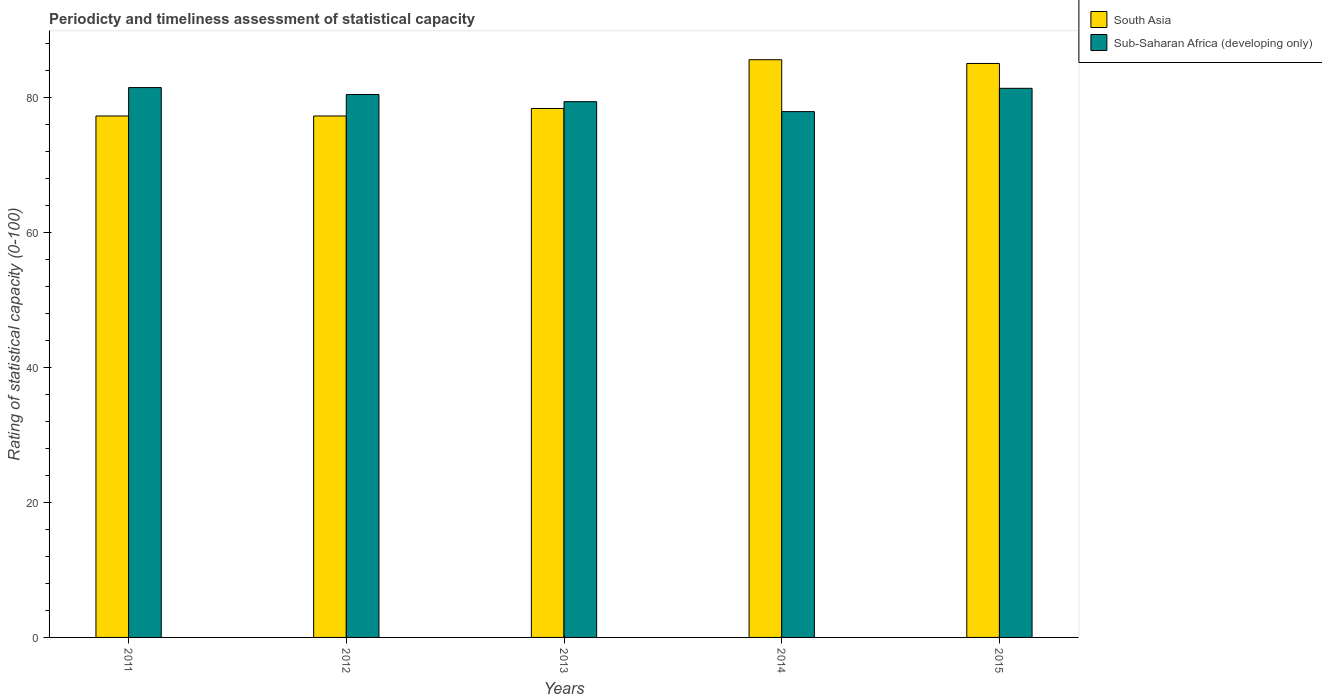How many groups of bars are there?
Provide a short and direct response. 5. How many bars are there on the 2nd tick from the left?
Make the answer very short. 2. How many bars are there on the 4th tick from the right?
Make the answer very short. 2. In how many cases, is the number of bars for a given year not equal to the number of legend labels?
Offer a terse response. 0. What is the rating of statistical capacity in South Asia in 2012?
Provide a succinct answer. 77.22. Across all years, what is the maximum rating of statistical capacity in Sub-Saharan Africa (developing only)?
Ensure brevity in your answer.  81.43. Across all years, what is the minimum rating of statistical capacity in Sub-Saharan Africa (developing only)?
Offer a very short reply. 77.87. In which year was the rating of statistical capacity in Sub-Saharan Africa (developing only) maximum?
Make the answer very short. 2011. In which year was the rating of statistical capacity in South Asia minimum?
Offer a terse response. 2011. What is the total rating of statistical capacity in South Asia in the graph?
Your answer should be compact. 403.33. What is the difference between the rating of statistical capacity in Sub-Saharan Africa (developing only) in 2011 and that in 2012?
Give a very brief answer. 1.03. What is the difference between the rating of statistical capacity in Sub-Saharan Africa (developing only) in 2015 and the rating of statistical capacity in South Asia in 2012?
Make the answer very short. 4.1. What is the average rating of statistical capacity in South Asia per year?
Ensure brevity in your answer.  80.67. In the year 2013, what is the difference between the rating of statistical capacity in South Asia and rating of statistical capacity in Sub-Saharan Africa (developing only)?
Provide a short and direct response. -1.01. What is the ratio of the rating of statistical capacity in Sub-Saharan Africa (developing only) in 2013 to that in 2014?
Your answer should be very brief. 1.02. Is the rating of statistical capacity in South Asia in 2013 less than that in 2015?
Ensure brevity in your answer.  Yes. Is the difference between the rating of statistical capacity in South Asia in 2012 and 2013 greater than the difference between the rating of statistical capacity in Sub-Saharan Africa (developing only) in 2012 and 2013?
Offer a terse response. No. What is the difference between the highest and the second highest rating of statistical capacity in South Asia?
Provide a short and direct response. 0.56. What is the difference between the highest and the lowest rating of statistical capacity in Sub-Saharan Africa (developing only)?
Offer a very short reply. 3.56. Is the sum of the rating of statistical capacity in South Asia in 2012 and 2013 greater than the maximum rating of statistical capacity in Sub-Saharan Africa (developing only) across all years?
Provide a succinct answer. Yes. What does the 1st bar from the left in 2014 represents?
Provide a succinct answer. South Asia. What does the 1st bar from the right in 2015 represents?
Give a very brief answer. Sub-Saharan Africa (developing only). How many bars are there?
Keep it short and to the point. 10. What is the difference between two consecutive major ticks on the Y-axis?
Provide a succinct answer. 20. Does the graph contain grids?
Keep it short and to the point. No. Where does the legend appear in the graph?
Keep it short and to the point. Top right. How are the legend labels stacked?
Give a very brief answer. Vertical. What is the title of the graph?
Your answer should be compact. Periodicty and timeliness assessment of statistical capacity. Does "Bangladesh" appear as one of the legend labels in the graph?
Provide a short and direct response. No. What is the label or title of the X-axis?
Offer a very short reply. Years. What is the label or title of the Y-axis?
Your answer should be compact. Rating of statistical capacity (0-100). What is the Rating of statistical capacity (0-100) of South Asia in 2011?
Provide a short and direct response. 77.22. What is the Rating of statistical capacity (0-100) in Sub-Saharan Africa (developing only) in 2011?
Provide a succinct answer. 81.43. What is the Rating of statistical capacity (0-100) of South Asia in 2012?
Make the answer very short. 77.22. What is the Rating of statistical capacity (0-100) in Sub-Saharan Africa (developing only) in 2012?
Your answer should be compact. 80.4. What is the Rating of statistical capacity (0-100) in South Asia in 2013?
Your response must be concise. 78.33. What is the Rating of statistical capacity (0-100) in Sub-Saharan Africa (developing only) in 2013?
Make the answer very short. 79.34. What is the Rating of statistical capacity (0-100) of South Asia in 2014?
Your response must be concise. 85.56. What is the Rating of statistical capacity (0-100) of Sub-Saharan Africa (developing only) in 2014?
Provide a succinct answer. 77.87. What is the Rating of statistical capacity (0-100) of South Asia in 2015?
Give a very brief answer. 85. What is the Rating of statistical capacity (0-100) of Sub-Saharan Africa (developing only) in 2015?
Make the answer very short. 81.32. Across all years, what is the maximum Rating of statistical capacity (0-100) in South Asia?
Ensure brevity in your answer.  85.56. Across all years, what is the maximum Rating of statistical capacity (0-100) in Sub-Saharan Africa (developing only)?
Offer a very short reply. 81.43. Across all years, what is the minimum Rating of statistical capacity (0-100) of South Asia?
Provide a succinct answer. 77.22. Across all years, what is the minimum Rating of statistical capacity (0-100) in Sub-Saharan Africa (developing only)?
Offer a terse response. 77.87. What is the total Rating of statistical capacity (0-100) in South Asia in the graph?
Keep it short and to the point. 403.33. What is the total Rating of statistical capacity (0-100) in Sub-Saharan Africa (developing only) in the graph?
Offer a very short reply. 400.35. What is the difference between the Rating of statistical capacity (0-100) of South Asia in 2011 and that in 2012?
Provide a succinct answer. -0. What is the difference between the Rating of statistical capacity (0-100) of Sub-Saharan Africa (developing only) in 2011 and that in 2012?
Give a very brief answer. 1.03. What is the difference between the Rating of statistical capacity (0-100) in South Asia in 2011 and that in 2013?
Provide a succinct answer. -1.11. What is the difference between the Rating of statistical capacity (0-100) in Sub-Saharan Africa (developing only) in 2011 and that in 2013?
Offer a terse response. 2.09. What is the difference between the Rating of statistical capacity (0-100) in South Asia in 2011 and that in 2014?
Provide a succinct answer. -8.33. What is the difference between the Rating of statistical capacity (0-100) in Sub-Saharan Africa (developing only) in 2011 and that in 2014?
Your answer should be very brief. 3.56. What is the difference between the Rating of statistical capacity (0-100) in South Asia in 2011 and that in 2015?
Your answer should be very brief. -7.78. What is the difference between the Rating of statistical capacity (0-100) in Sub-Saharan Africa (developing only) in 2011 and that in 2015?
Offer a terse response. 0.11. What is the difference between the Rating of statistical capacity (0-100) in South Asia in 2012 and that in 2013?
Your answer should be very brief. -1.11. What is the difference between the Rating of statistical capacity (0-100) of Sub-Saharan Africa (developing only) in 2012 and that in 2013?
Your response must be concise. 1.06. What is the difference between the Rating of statistical capacity (0-100) in South Asia in 2012 and that in 2014?
Keep it short and to the point. -8.33. What is the difference between the Rating of statistical capacity (0-100) of Sub-Saharan Africa (developing only) in 2012 and that in 2014?
Offer a very short reply. 2.53. What is the difference between the Rating of statistical capacity (0-100) in South Asia in 2012 and that in 2015?
Your answer should be compact. -7.78. What is the difference between the Rating of statistical capacity (0-100) in Sub-Saharan Africa (developing only) in 2012 and that in 2015?
Offer a terse response. -0.92. What is the difference between the Rating of statistical capacity (0-100) in South Asia in 2013 and that in 2014?
Offer a very short reply. -7.22. What is the difference between the Rating of statistical capacity (0-100) in Sub-Saharan Africa (developing only) in 2013 and that in 2014?
Make the answer very short. 1.47. What is the difference between the Rating of statistical capacity (0-100) of South Asia in 2013 and that in 2015?
Provide a short and direct response. -6.67. What is the difference between the Rating of statistical capacity (0-100) in Sub-Saharan Africa (developing only) in 2013 and that in 2015?
Your answer should be compact. -1.98. What is the difference between the Rating of statistical capacity (0-100) of South Asia in 2014 and that in 2015?
Your answer should be very brief. 0.56. What is the difference between the Rating of statistical capacity (0-100) in Sub-Saharan Africa (developing only) in 2014 and that in 2015?
Provide a succinct answer. -3.45. What is the difference between the Rating of statistical capacity (0-100) in South Asia in 2011 and the Rating of statistical capacity (0-100) in Sub-Saharan Africa (developing only) in 2012?
Your response must be concise. -3.17. What is the difference between the Rating of statistical capacity (0-100) in South Asia in 2011 and the Rating of statistical capacity (0-100) in Sub-Saharan Africa (developing only) in 2013?
Offer a terse response. -2.12. What is the difference between the Rating of statistical capacity (0-100) of South Asia in 2011 and the Rating of statistical capacity (0-100) of Sub-Saharan Africa (developing only) in 2014?
Your answer should be compact. -0.65. What is the difference between the Rating of statistical capacity (0-100) of South Asia in 2011 and the Rating of statistical capacity (0-100) of Sub-Saharan Africa (developing only) in 2015?
Your response must be concise. -4.1. What is the difference between the Rating of statistical capacity (0-100) of South Asia in 2012 and the Rating of statistical capacity (0-100) of Sub-Saharan Africa (developing only) in 2013?
Your response must be concise. -2.12. What is the difference between the Rating of statistical capacity (0-100) of South Asia in 2012 and the Rating of statistical capacity (0-100) of Sub-Saharan Africa (developing only) in 2014?
Provide a succinct answer. -0.65. What is the difference between the Rating of statistical capacity (0-100) of South Asia in 2012 and the Rating of statistical capacity (0-100) of Sub-Saharan Africa (developing only) in 2015?
Provide a short and direct response. -4.1. What is the difference between the Rating of statistical capacity (0-100) in South Asia in 2013 and the Rating of statistical capacity (0-100) in Sub-Saharan Africa (developing only) in 2014?
Keep it short and to the point. 0.47. What is the difference between the Rating of statistical capacity (0-100) of South Asia in 2013 and the Rating of statistical capacity (0-100) of Sub-Saharan Africa (developing only) in 2015?
Offer a very short reply. -2.98. What is the difference between the Rating of statistical capacity (0-100) in South Asia in 2014 and the Rating of statistical capacity (0-100) in Sub-Saharan Africa (developing only) in 2015?
Give a very brief answer. 4.24. What is the average Rating of statistical capacity (0-100) in South Asia per year?
Your answer should be compact. 80.67. What is the average Rating of statistical capacity (0-100) in Sub-Saharan Africa (developing only) per year?
Provide a succinct answer. 80.07. In the year 2011, what is the difference between the Rating of statistical capacity (0-100) in South Asia and Rating of statistical capacity (0-100) in Sub-Saharan Africa (developing only)?
Provide a succinct answer. -4.21. In the year 2012, what is the difference between the Rating of statistical capacity (0-100) in South Asia and Rating of statistical capacity (0-100) in Sub-Saharan Africa (developing only)?
Give a very brief answer. -3.17. In the year 2013, what is the difference between the Rating of statistical capacity (0-100) of South Asia and Rating of statistical capacity (0-100) of Sub-Saharan Africa (developing only)?
Your answer should be very brief. -1.01. In the year 2014, what is the difference between the Rating of statistical capacity (0-100) in South Asia and Rating of statistical capacity (0-100) in Sub-Saharan Africa (developing only)?
Your response must be concise. 7.69. In the year 2015, what is the difference between the Rating of statistical capacity (0-100) in South Asia and Rating of statistical capacity (0-100) in Sub-Saharan Africa (developing only)?
Keep it short and to the point. 3.68. What is the ratio of the Rating of statistical capacity (0-100) in Sub-Saharan Africa (developing only) in 2011 to that in 2012?
Provide a succinct answer. 1.01. What is the ratio of the Rating of statistical capacity (0-100) of South Asia in 2011 to that in 2013?
Your answer should be very brief. 0.99. What is the ratio of the Rating of statistical capacity (0-100) of Sub-Saharan Africa (developing only) in 2011 to that in 2013?
Provide a succinct answer. 1.03. What is the ratio of the Rating of statistical capacity (0-100) in South Asia in 2011 to that in 2014?
Offer a terse response. 0.9. What is the ratio of the Rating of statistical capacity (0-100) in Sub-Saharan Africa (developing only) in 2011 to that in 2014?
Provide a succinct answer. 1.05. What is the ratio of the Rating of statistical capacity (0-100) of South Asia in 2011 to that in 2015?
Provide a short and direct response. 0.91. What is the ratio of the Rating of statistical capacity (0-100) in South Asia in 2012 to that in 2013?
Provide a short and direct response. 0.99. What is the ratio of the Rating of statistical capacity (0-100) of Sub-Saharan Africa (developing only) in 2012 to that in 2013?
Provide a short and direct response. 1.01. What is the ratio of the Rating of statistical capacity (0-100) of South Asia in 2012 to that in 2014?
Offer a terse response. 0.9. What is the ratio of the Rating of statistical capacity (0-100) in Sub-Saharan Africa (developing only) in 2012 to that in 2014?
Your response must be concise. 1.03. What is the ratio of the Rating of statistical capacity (0-100) of South Asia in 2012 to that in 2015?
Keep it short and to the point. 0.91. What is the ratio of the Rating of statistical capacity (0-100) of Sub-Saharan Africa (developing only) in 2012 to that in 2015?
Your response must be concise. 0.99. What is the ratio of the Rating of statistical capacity (0-100) in South Asia in 2013 to that in 2014?
Keep it short and to the point. 0.92. What is the ratio of the Rating of statistical capacity (0-100) of Sub-Saharan Africa (developing only) in 2013 to that in 2014?
Keep it short and to the point. 1.02. What is the ratio of the Rating of statistical capacity (0-100) of South Asia in 2013 to that in 2015?
Your answer should be compact. 0.92. What is the ratio of the Rating of statistical capacity (0-100) in Sub-Saharan Africa (developing only) in 2013 to that in 2015?
Your answer should be compact. 0.98. What is the ratio of the Rating of statistical capacity (0-100) in Sub-Saharan Africa (developing only) in 2014 to that in 2015?
Ensure brevity in your answer.  0.96. What is the difference between the highest and the second highest Rating of statistical capacity (0-100) of South Asia?
Your response must be concise. 0.56. What is the difference between the highest and the second highest Rating of statistical capacity (0-100) of Sub-Saharan Africa (developing only)?
Give a very brief answer. 0.11. What is the difference between the highest and the lowest Rating of statistical capacity (0-100) in South Asia?
Your answer should be compact. 8.33. What is the difference between the highest and the lowest Rating of statistical capacity (0-100) in Sub-Saharan Africa (developing only)?
Your response must be concise. 3.56. 